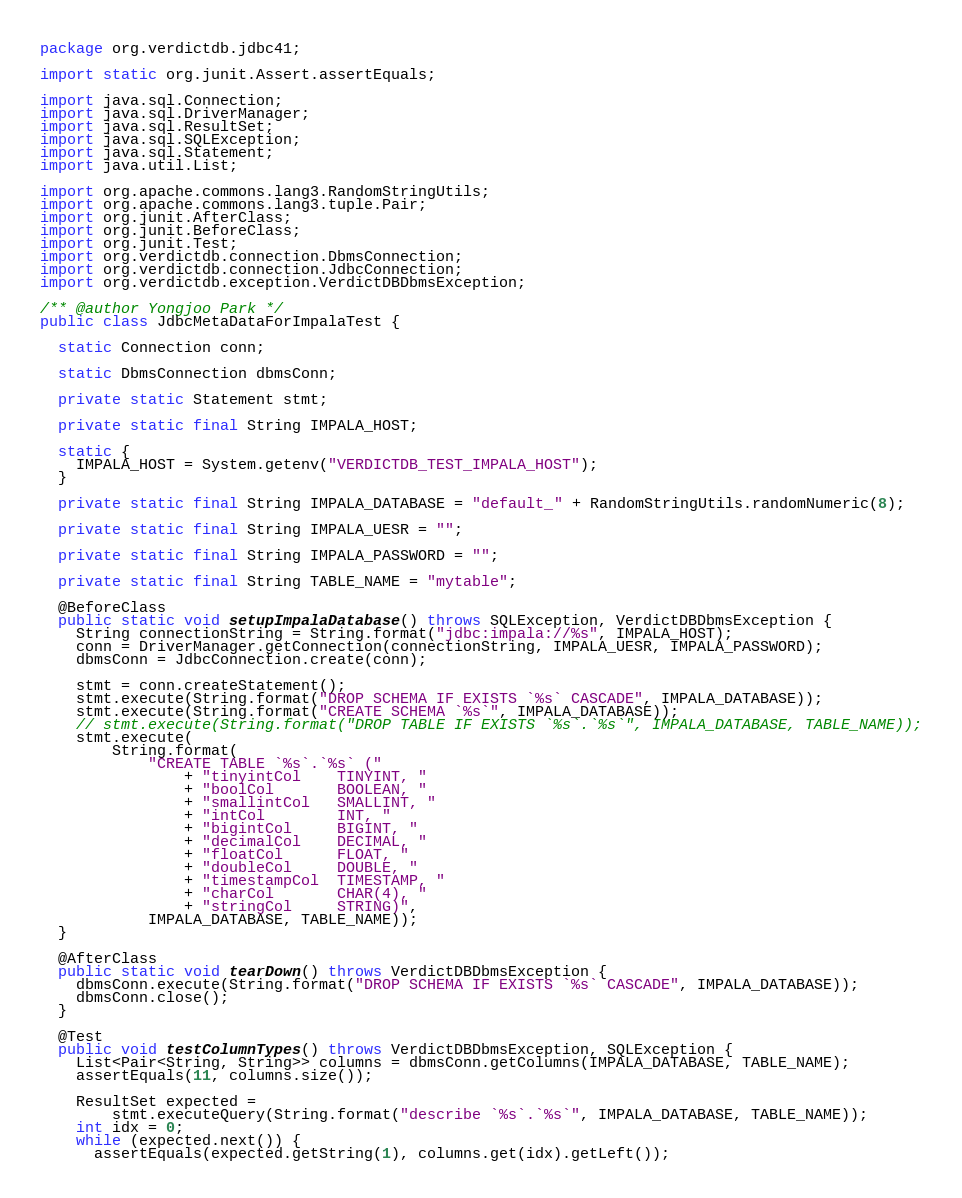<code> <loc_0><loc_0><loc_500><loc_500><_Java_>package org.verdictdb.jdbc41;

import static org.junit.Assert.assertEquals;

import java.sql.Connection;
import java.sql.DriverManager;
import java.sql.ResultSet;
import java.sql.SQLException;
import java.sql.Statement;
import java.util.List;

import org.apache.commons.lang3.RandomStringUtils;
import org.apache.commons.lang3.tuple.Pair;
import org.junit.AfterClass;
import org.junit.BeforeClass;
import org.junit.Test;
import org.verdictdb.connection.DbmsConnection;
import org.verdictdb.connection.JdbcConnection;
import org.verdictdb.exception.VerdictDBDbmsException;

/** @author Yongjoo Park */
public class JdbcMetaDataForImpalaTest {

  static Connection conn;

  static DbmsConnection dbmsConn;

  private static Statement stmt;

  private static final String IMPALA_HOST;

  static {
    IMPALA_HOST = System.getenv("VERDICTDB_TEST_IMPALA_HOST");
  }

  private static final String IMPALA_DATABASE = "default_" + RandomStringUtils.randomNumeric(8);

  private static final String IMPALA_UESR = "";

  private static final String IMPALA_PASSWORD = "";

  private static final String TABLE_NAME = "mytable";

  @BeforeClass
  public static void setupImpalaDatabase() throws SQLException, VerdictDBDbmsException {
    String connectionString = String.format("jdbc:impala://%s", IMPALA_HOST);
    conn = DriverManager.getConnection(connectionString, IMPALA_UESR, IMPALA_PASSWORD);
    dbmsConn = JdbcConnection.create(conn);

    stmt = conn.createStatement();
    stmt.execute(String.format("DROP SCHEMA IF EXISTS `%s` CASCADE", IMPALA_DATABASE));
    stmt.execute(String.format("CREATE SCHEMA `%s`", IMPALA_DATABASE));
    // stmt.execute(String.format("DROP TABLE IF EXISTS `%s`.`%s`", IMPALA_DATABASE, TABLE_NAME));
    stmt.execute(
        String.format(
            "CREATE TABLE `%s`.`%s` ("
                + "tinyintCol    TINYINT, "
                + "boolCol       BOOLEAN, "
                + "smallintCol   SMALLINT, "
                + "intCol        INT, "
                + "bigintCol     BIGINT, "
                + "decimalCol    DECIMAL, "
                + "floatCol      FLOAT, "
                + "doubleCol     DOUBLE, "
                + "timestampCol  TIMESTAMP, "
                + "charCol       CHAR(4), "
                + "stringCol     STRING)",
            IMPALA_DATABASE, TABLE_NAME));
  }

  @AfterClass
  public static void tearDown() throws VerdictDBDbmsException {
    dbmsConn.execute(String.format("DROP SCHEMA IF EXISTS `%s` CASCADE", IMPALA_DATABASE));
    dbmsConn.close();
  }

  @Test
  public void testColumnTypes() throws VerdictDBDbmsException, SQLException {
    List<Pair<String, String>> columns = dbmsConn.getColumns(IMPALA_DATABASE, TABLE_NAME);
    assertEquals(11, columns.size());

    ResultSet expected =
        stmt.executeQuery(String.format("describe `%s`.`%s`", IMPALA_DATABASE, TABLE_NAME));
    int idx = 0;
    while (expected.next()) {
      assertEquals(expected.getString(1), columns.get(idx).getLeft());</code> 